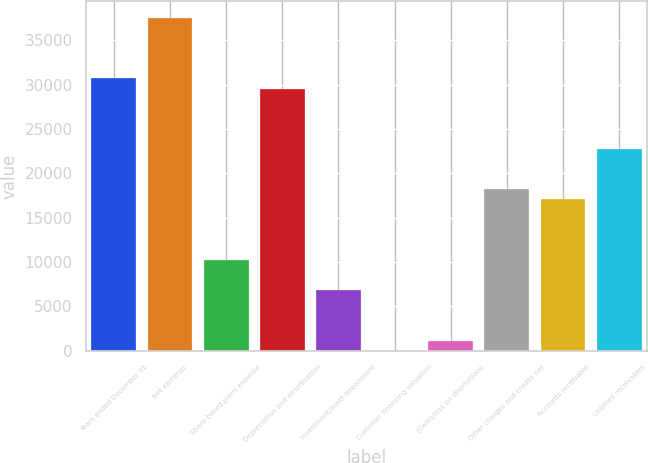Convert chart. <chart><loc_0><loc_0><loc_500><loc_500><bar_chart><fcel>Years ended December 31<fcel>Net earnings<fcel>Share-based plans expense<fcel>Depreciation and amortization<fcel>Investment/asset impairment<fcel>Customer financing valuation<fcel>(Gain)/loss on dispositions<fcel>Other charges and credits net<fcel>Accounts receivable<fcel>Unbilled receivables<nl><fcel>30689.8<fcel>37508.2<fcel>10234.6<fcel>29553.4<fcel>6825.4<fcel>7<fcel>1143.4<fcel>18189.4<fcel>17053<fcel>22735<nl></chart> 